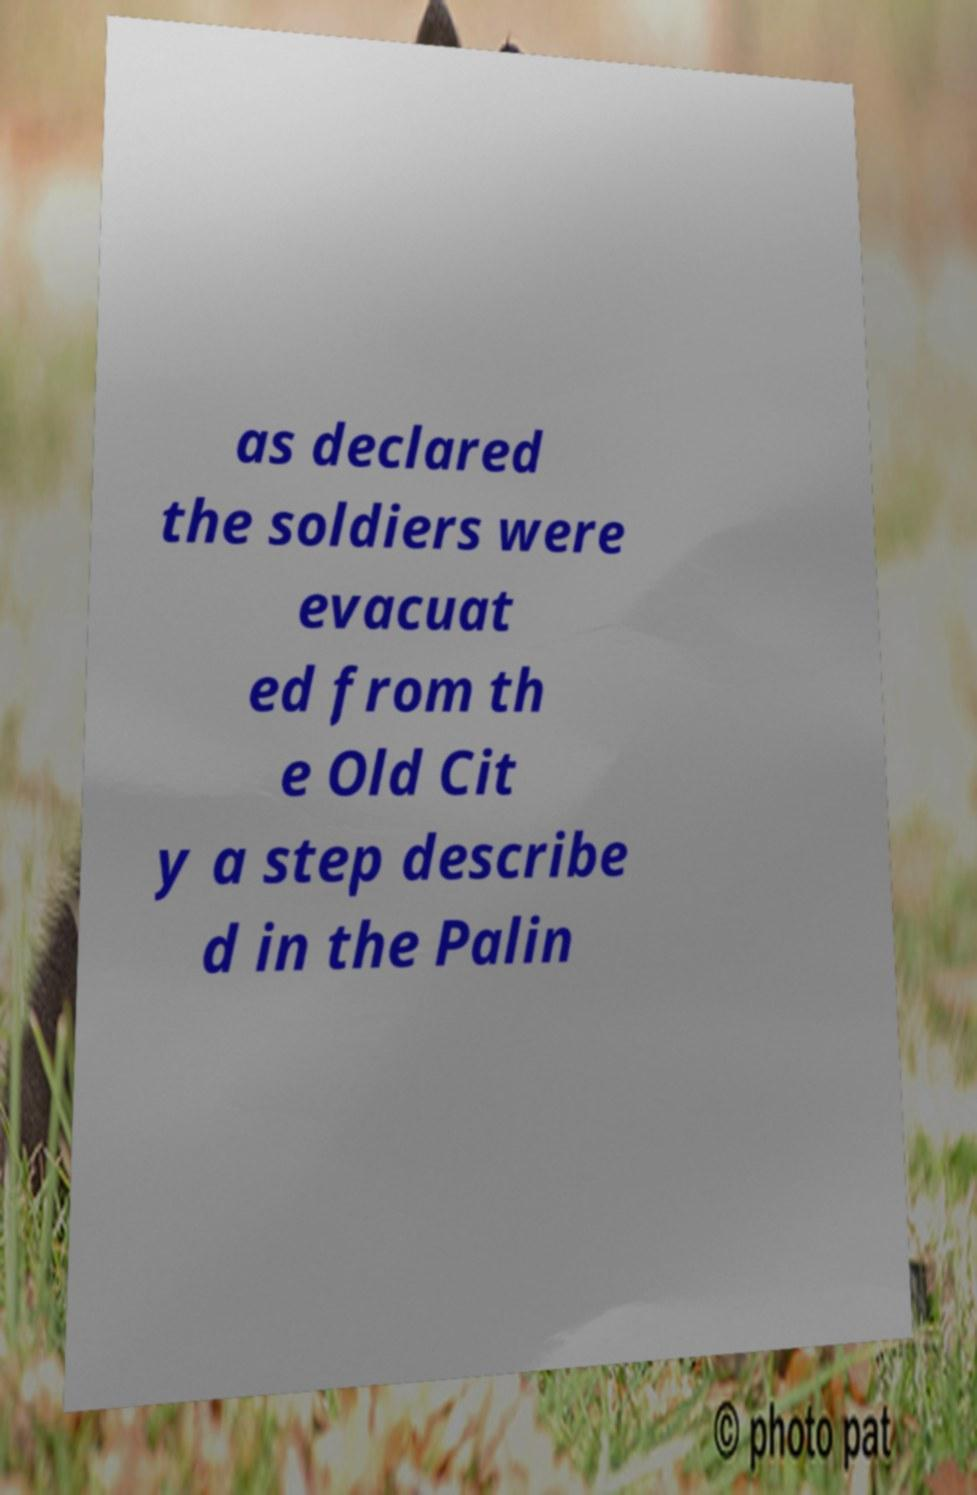Please read and relay the text visible in this image. What does it say? as declared the soldiers were evacuat ed from th e Old Cit y a step describe d in the Palin 